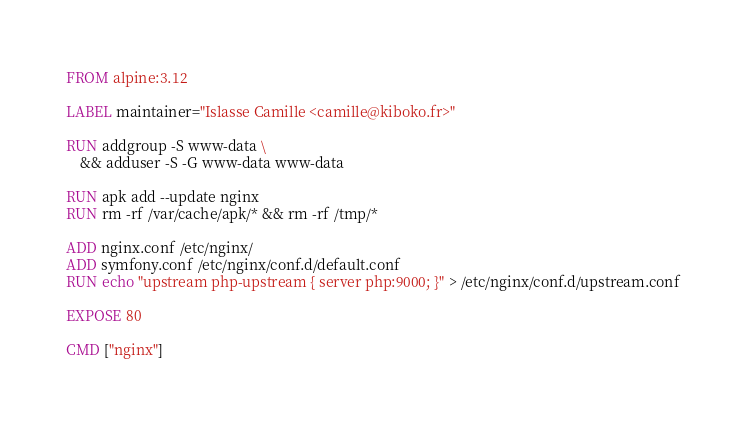<code> <loc_0><loc_0><loc_500><loc_500><_Dockerfile_>FROM alpine:3.12

LABEL maintainer="Islasse Camille <camille@kiboko.fr>"

RUN addgroup -S www-data \
    && adduser -S -G www-data www-data

RUN apk add --update nginx
RUN rm -rf /var/cache/apk/* && rm -rf /tmp/*

ADD nginx.conf /etc/nginx/
ADD symfony.conf /etc/nginx/conf.d/default.conf
RUN echo "upstream php-upstream { server php:9000; }" > /etc/nginx/conf.d/upstream.conf

EXPOSE 80

CMD ["nginx"]</code> 